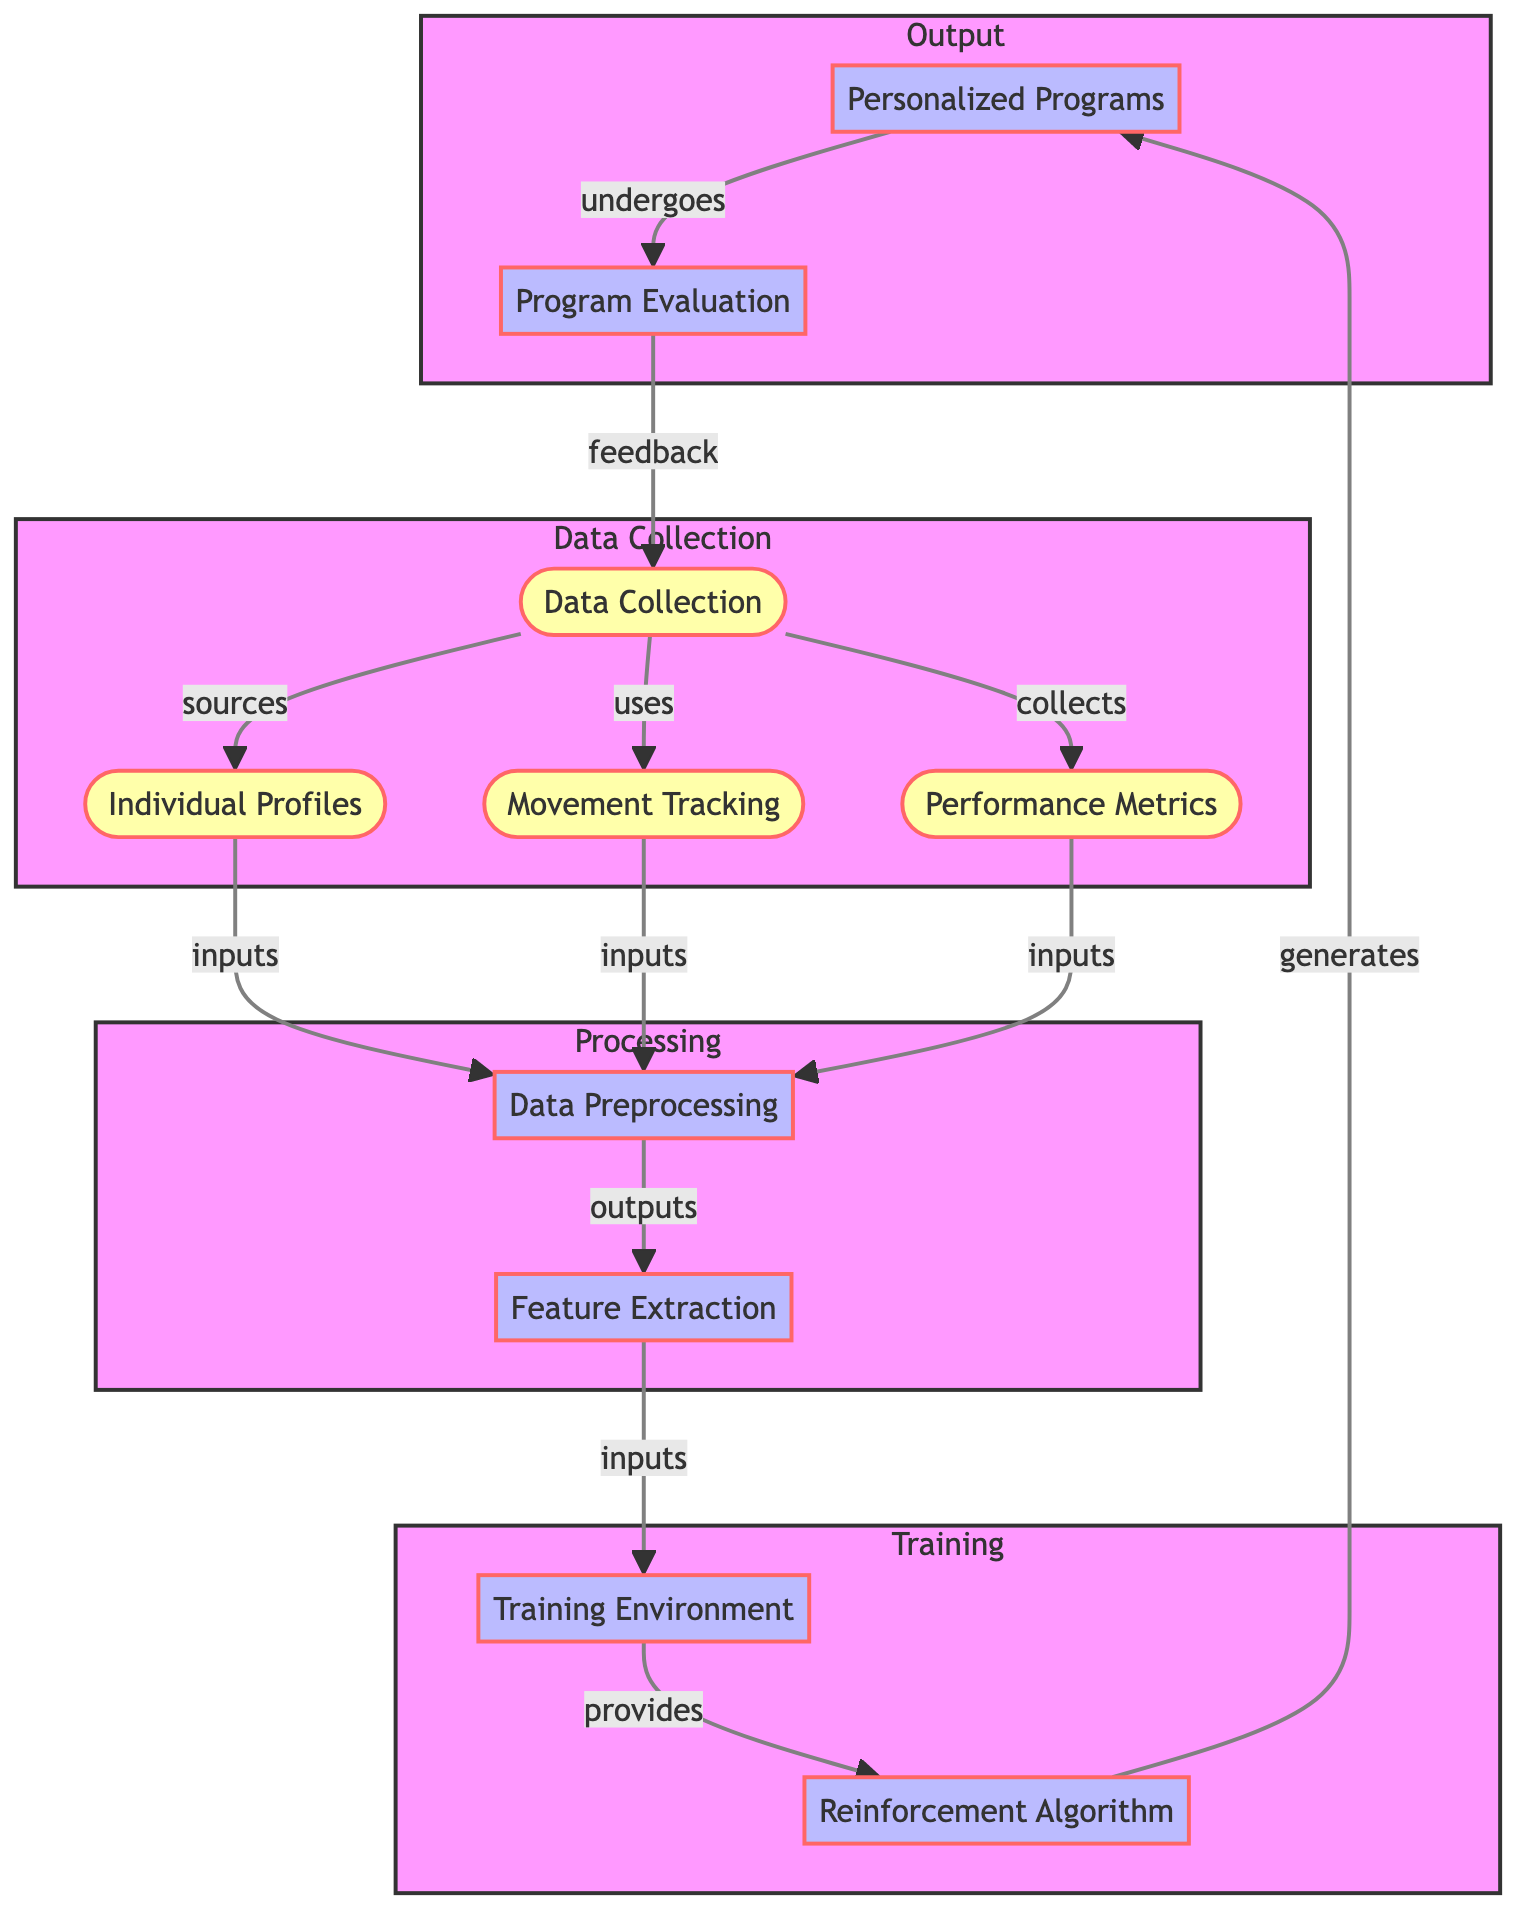What is the first step in the process? The first step in the process is "Data Collection," which feeds into individual profiles, movement tracking, and performance metrics.
Answer: Data Collection How many major subgraphs are there in the diagram? The diagram contains four major subgraphs: Data Collection, Processing, Training, and Output.
Answer: Four What is the output of the data preprocessing step? The output of the data preprocessing step is "Feature Extraction," which indicates that data has been organized for further processing.
Answer: Feature Extraction Which node generates personalized programs? The "Reinforcement Algorithm" node generates "Personalized Programs" as part of the training process.
Answer: Reinforcement Algorithm What feedback mechanism is depicted in the diagram? The diagram shows a feedback loop where "Program Evaluation" provides feedback to "Data Collection," indicating a cycle of improvement.
Answer: Feedback loop Which nodes input to data preprocessing? The nodes that input to data preprocessing are "Individual Profiles," "Movement Tracking," and "Performance Metrics."
Answer: Three nodes How does Feature Extraction relate to the Training Environment? "Feature Extraction" outputs data to the "Training Environment," indicating that the extracted features feed into the environment for training.
Answer: Outputs What does the Program Evaluation undergo? "Personalized Programs" undergo "Program Evaluation," which assesses the effectiveness of the programs created by the reinforcement learning algorithm.
Answer: Program Evaluation How does training environment contribute to personalized programs? The "Training Environment" provides inputs to the "Reinforcement Algorithm," which in turn generates "Personalized Programs," illustrating a flow of training data.
Answer: Provides inputs 